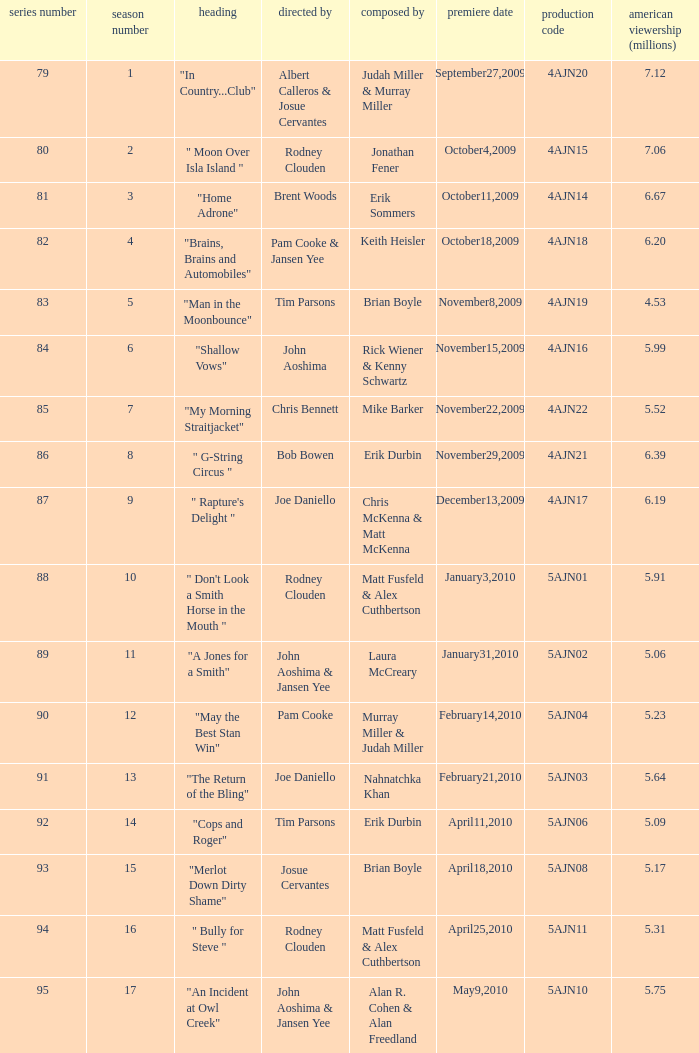Name who wrote 5ajn11 Matt Fusfeld & Alex Cuthbertson. 